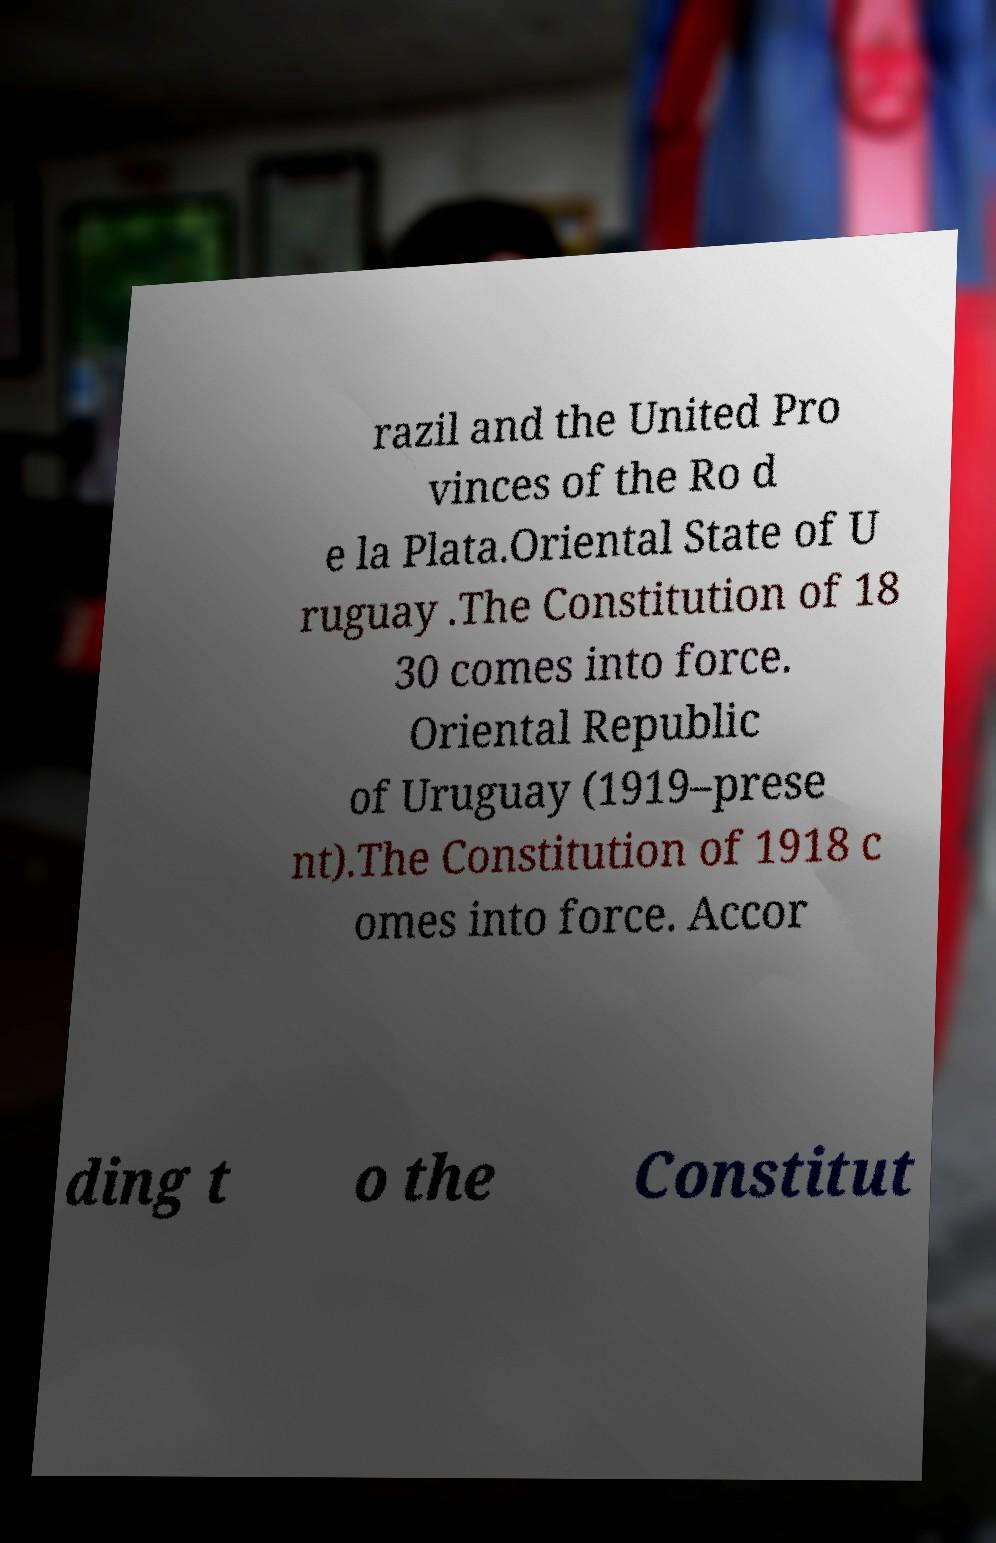Please identify and transcribe the text found in this image. razil and the United Pro vinces of the Ro d e la Plata.Oriental State of U ruguay .The Constitution of 18 30 comes into force. Oriental Republic of Uruguay (1919–prese nt).The Constitution of 1918 c omes into force. Accor ding t o the Constitut 